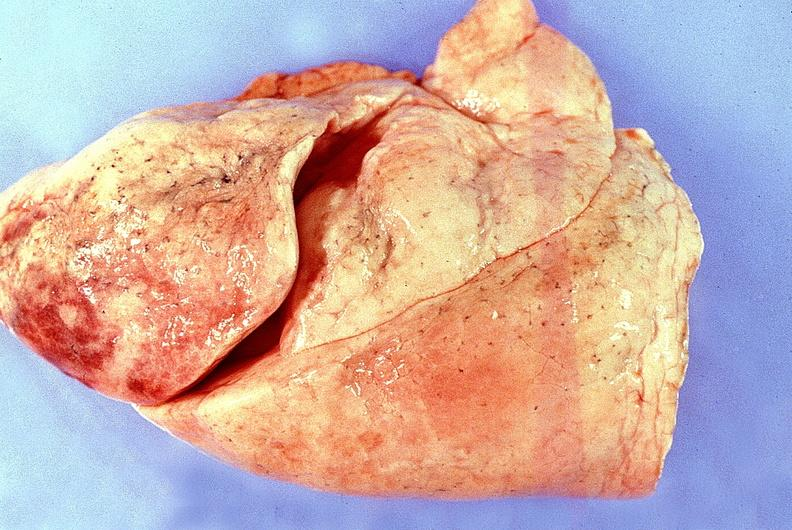where is this?
Answer the question using a single word or phrase. Lung 